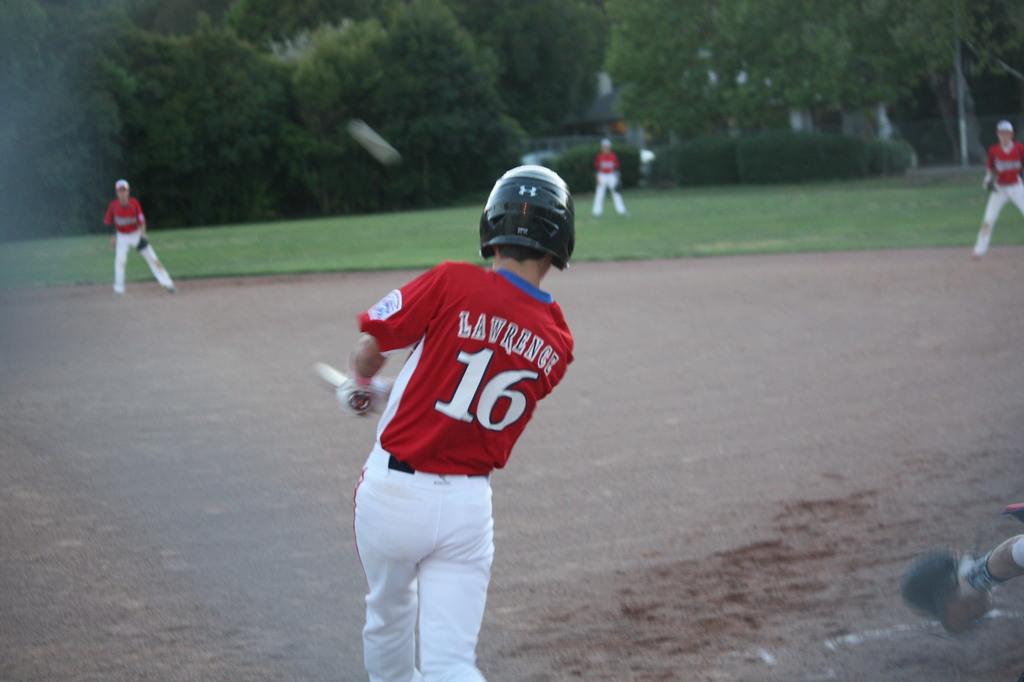Which player is at bat?
Keep it short and to the point. Lawrence. What is the number on the jersey?
Provide a short and direct response. 16. 